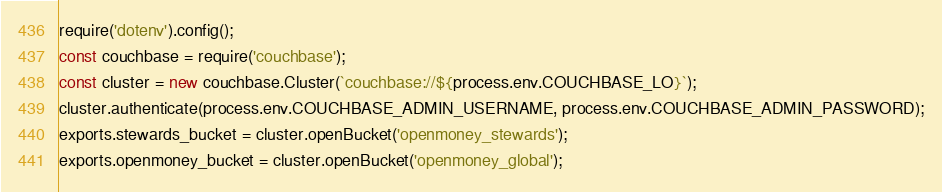<code> <loc_0><loc_0><loc_500><loc_500><_JavaScript_>require('dotenv').config();
const couchbase = require('couchbase');
const cluster = new couchbase.Cluster(`couchbase://${process.env.COUCHBASE_LO}`);
cluster.authenticate(process.env.COUCHBASE_ADMIN_USERNAME, process.env.COUCHBASE_ADMIN_PASSWORD);
exports.stewards_bucket = cluster.openBucket('openmoney_stewards');
exports.openmoney_bucket = cluster.openBucket('openmoney_global');</code> 